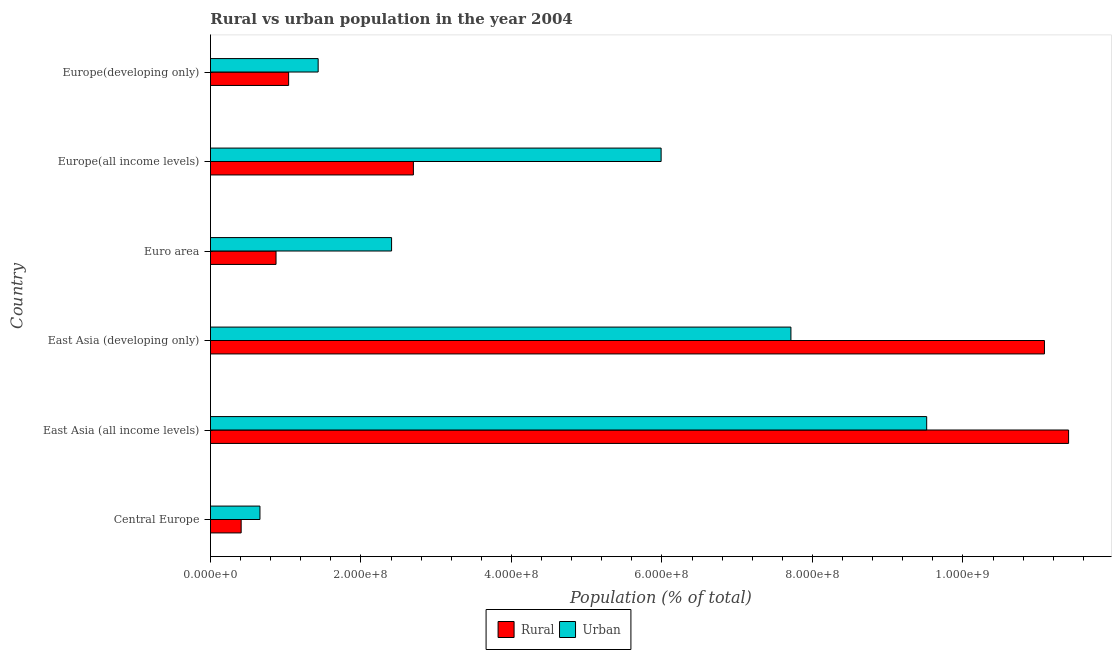How many different coloured bars are there?
Offer a terse response. 2. How many groups of bars are there?
Provide a short and direct response. 6. What is the label of the 4th group of bars from the top?
Offer a very short reply. East Asia (developing only). In how many cases, is the number of bars for a given country not equal to the number of legend labels?
Your answer should be compact. 0. What is the urban population density in Europe(developing only)?
Provide a short and direct response. 1.43e+08. Across all countries, what is the maximum rural population density?
Provide a short and direct response. 1.14e+09. Across all countries, what is the minimum urban population density?
Provide a short and direct response. 6.57e+07. In which country was the urban population density maximum?
Offer a terse response. East Asia (all income levels). In which country was the rural population density minimum?
Your response must be concise. Central Europe. What is the total urban population density in the graph?
Your response must be concise. 2.77e+09. What is the difference between the urban population density in Central Europe and that in Euro area?
Offer a terse response. -1.75e+08. What is the difference between the urban population density in Central Europe and the rural population density in Europe(all income levels)?
Offer a terse response. -2.04e+08. What is the average urban population density per country?
Keep it short and to the point. 4.62e+08. What is the difference between the urban population density and rural population density in East Asia (all income levels)?
Your response must be concise. -1.89e+08. In how many countries, is the urban population density greater than 360000000 %?
Make the answer very short. 3. What is the ratio of the urban population density in East Asia (all income levels) to that in Europe(all income levels)?
Provide a short and direct response. 1.59. Is the rural population density in Euro area less than that in Europe(all income levels)?
Your answer should be very brief. Yes. Is the difference between the rural population density in East Asia (all income levels) and Europe(all income levels) greater than the difference between the urban population density in East Asia (all income levels) and Europe(all income levels)?
Your response must be concise. Yes. What is the difference between the highest and the second highest urban population density?
Your answer should be compact. 1.80e+08. What is the difference between the highest and the lowest urban population density?
Provide a short and direct response. 8.86e+08. In how many countries, is the urban population density greater than the average urban population density taken over all countries?
Provide a succinct answer. 3. What does the 1st bar from the top in East Asia (developing only) represents?
Your response must be concise. Urban. What does the 1st bar from the bottom in Euro area represents?
Provide a short and direct response. Rural. Are all the bars in the graph horizontal?
Offer a very short reply. Yes. What is the difference between two consecutive major ticks on the X-axis?
Offer a terse response. 2.00e+08. Does the graph contain grids?
Give a very brief answer. No. What is the title of the graph?
Make the answer very short. Rural vs urban population in the year 2004. What is the label or title of the X-axis?
Offer a terse response. Population (% of total). What is the label or title of the Y-axis?
Give a very brief answer. Country. What is the Population (% of total) of Rural in Central Europe?
Your answer should be compact. 4.08e+07. What is the Population (% of total) of Urban in Central Europe?
Your response must be concise. 6.57e+07. What is the Population (% of total) in Rural in East Asia (all income levels)?
Offer a very short reply. 1.14e+09. What is the Population (% of total) in Urban in East Asia (all income levels)?
Ensure brevity in your answer.  9.52e+08. What is the Population (% of total) of Rural in East Asia (developing only)?
Offer a terse response. 1.11e+09. What is the Population (% of total) of Urban in East Asia (developing only)?
Offer a terse response. 7.71e+08. What is the Population (% of total) in Rural in Euro area?
Your answer should be very brief. 8.71e+07. What is the Population (% of total) of Urban in Euro area?
Make the answer very short. 2.41e+08. What is the Population (% of total) of Rural in Europe(all income levels)?
Your answer should be compact. 2.70e+08. What is the Population (% of total) in Urban in Europe(all income levels)?
Make the answer very short. 5.99e+08. What is the Population (% of total) of Rural in Europe(developing only)?
Ensure brevity in your answer.  1.04e+08. What is the Population (% of total) in Urban in Europe(developing only)?
Your answer should be very brief. 1.43e+08. Across all countries, what is the maximum Population (% of total) in Rural?
Offer a terse response. 1.14e+09. Across all countries, what is the maximum Population (% of total) of Urban?
Offer a very short reply. 9.52e+08. Across all countries, what is the minimum Population (% of total) in Rural?
Provide a succinct answer. 4.08e+07. Across all countries, what is the minimum Population (% of total) of Urban?
Your response must be concise. 6.57e+07. What is the total Population (% of total) in Rural in the graph?
Keep it short and to the point. 2.75e+09. What is the total Population (% of total) in Urban in the graph?
Keep it short and to the point. 2.77e+09. What is the difference between the Population (% of total) in Rural in Central Europe and that in East Asia (all income levels)?
Offer a terse response. -1.10e+09. What is the difference between the Population (% of total) of Urban in Central Europe and that in East Asia (all income levels)?
Offer a very short reply. -8.86e+08. What is the difference between the Population (% of total) in Rural in Central Europe and that in East Asia (developing only)?
Give a very brief answer. -1.07e+09. What is the difference between the Population (% of total) of Urban in Central Europe and that in East Asia (developing only)?
Provide a succinct answer. -7.06e+08. What is the difference between the Population (% of total) in Rural in Central Europe and that in Euro area?
Offer a terse response. -4.63e+07. What is the difference between the Population (% of total) in Urban in Central Europe and that in Euro area?
Keep it short and to the point. -1.75e+08. What is the difference between the Population (% of total) of Rural in Central Europe and that in Europe(all income levels)?
Give a very brief answer. -2.29e+08. What is the difference between the Population (% of total) in Urban in Central Europe and that in Europe(all income levels)?
Your answer should be compact. -5.33e+08. What is the difference between the Population (% of total) of Rural in Central Europe and that in Europe(developing only)?
Your answer should be compact. -6.31e+07. What is the difference between the Population (% of total) of Urban in Central Europe and that in Europe(developing only)?
Provide a short and direct response. -7.74e+07. What is the difference between the Population (% of total) of Rural in East Asia (all income levels) and that in East Asia (developing only)?
Offer a very short reply. 3.21e+07. What is the difference between the Population (% of total) of Urban in East Asia (all income levels) and that in East Asia (developing only)?
Your answer should be very brief. 1.80e+08. What is the difference between the Population (% of total) of Rural in East Asia (all income levels) and that in Euro area?
Give a very brief answer. 1.05e+09. What is the difference between the Population (% of total) of Urban in East Asia (all income levels) and that in Euro area?
Offer a terse response. 7.11e+08. What is the difference between the Population (% of total) of Rural in East Asia (all income levels) and that in Europe(all income levels)?
Ensure brevity in your answer.  8.71e+08. What is the difference between the Population (% of total) of Urban in East Asia (all income levels) and that in Europe(all income levels)?
Provide a short and direct response. 3.53e+08. What is the difference between the Population (% of total) in Rural in East Asia (all income levels) and that in Europe(developing only)?
Keep it short and to the point. 1.04e+09. What is the difference between the Population (% of total) of Urban in East Asia (all income levels) and that in Europe(developing only)?
Offer a very short reply. 8.09e+08. What is the difference between the Population (% of total) in Rural in East Asia (developing only) and that in Euro area?
Make the answer very short. 1.02e+09. What is the difference between the Population (% of total) of Urban in East Asia (developing only) and that in Euro area?
Ensure brevity in your answer.  5.31e+08. What is the difference between the Population (% of total) in Rural in East Asia (developing only) and that in Europe(all income levels)?
Provide a short and direct response. 8.39e+08. What is the difference between the Population (% of total) of Urban in East Asia (developing only) and that in Europe(all income levels)?
Offer a terse response. 1.72e+08. What is the difference between the Population (% of total) in Rural in East Asia (developing only) and that in Europe(developing only)?
Offer a terse response. 1.00e+09. What is the difference between the Population (% of total) in Urban in East Asia (developing only) and that in Europe(developing only)?
Your response must be concise. 6.28e+08. What is the difference between the Population (% of total) in Rural in Euro area and that in Europe(all income levels)?
Give a very brief answer. -1.83e+08. What is the difference between the Population (% of total) in Urban in Euro area and that in Europe(all income levels)?
Keep it short and to the point. -3.58e+08. What is the difference between the Population (% of total) of Rural in Euro area and that in Europe(developing only)?
Make the answer very short. -1.67e+07. What is the difference between the Population (% of total) of Urban in Euro area and that in Europe(developing only)?
Ensure brevity in your answer.  9.76e+07. What is the difference between the Population (% of total) in Rural in Europe(all income levels) and that in Europe(developing only)?
Ensure brevity in your answer.  1.66e+08. What is the difference between the Population (% of total) of Urban in Europe(all income levels) and that in Europe(developing only)?
Ensure brevity in your answer.  4.56e+08. What is the difference between the Population (% of total) of Rural in Central Europe and the Population (% of total) of Urban in East Asia (all income levels)?
Offer a terse response. -9.11e+08. What is the difference between the Population (% of total) of Rural in Central Europe and the Population (% of total) of Urban in East Asia (developing only)?
Ensure brevity in your answer.  -7.31e+08. What is the difference between the Population (% of total) in Rural in Central Europe and the Population (% of total) in Urban in Euro area?
Provide a short and direct response. -2.00e+08. What is the difference between the Population (% of total) of Rural in Central Europe and the Population (% of total) of Urban in Europe(all income levels)?
Keep it short and to the point. -5.58e+08. What is the difference between the Population (% of total) in Rural in Central Europe and the Population (% of total) in Urban in Europe(developing only)?
Offer a very short reply. -1.02e+08. What is the difference between the Population (% of total) in Rural in East Asia (all income levels) and the Population (% of total) in Urban in East Asia (developing only)?
Keep it short and to the point. 3.69e+08. What is the difference between the Population (% of total) in Rural in East Asia (all income levels) and the Population (% of total) in Urban in Euro area?
Provide a short and direct response. 9.00e+08. What is the difference between the Population (% of total) in Rural in East Asia (all income levels) and the Population (% of total) in Urban in Europe(all income levels)?
Provide a short and direct response. 5.41e+08. What is the difference between the Population (% of total) of Rural in East Asia (all income levels) and the Population (% of total) of Urban in Europe(developing only)?
Your answer should be very brief. 9.97e+08. What is the difference between the Population (% of total) in Rural in East Asia (developing only) and the Population (% of total) in Urban in Euro area?
Give a very brief answer. 8.68e+08. What is the difference between the Population (% of total) in Rural in East Asia (developing only) and the Population (% of total) in Urban in Europe(all income levels)?
Your answer should be compact. 5.09e+08. What is the difference between the Population (% of total) in Rural in East Asia (developing only) and the Population (% of total) in Urban in Europe(developing only)?
Ensure brevity in your answer.  9.65e+08. What is the difference between the Population (% of total) in Rural in Euro area and the Population (% of total) in Urban in Europe(all income levels)?
Your answer should be very brief. -5.12e+08. What is the difference between the Population (% of total) in Rural in Euro area and the Population (% of total) in Urban in Europe(developing only)?
Make the answer very short. -5.60e+07. What is the difference between the Population (% of total) of Rural in Europe(all income levels) and the Population (% of total) of Urban in Europe(developing only)?
Ensure brevity in your answer.  1.27e+08. What is the average Population (% of total) in Rural per country?
Your answer should be very brief. 4.58e+08. What is the average Population (% of total) in Urban per country?
Provide a succinct answer. 4.62e+08. What is the difference between the Population (% of total) of Rural and Population (% of total) of Urban in Central Europe?
Ensure brevity in your answer.  -2.50e+07. What is the difference between the Population (% of total) of Rural and Population (% of total) of Urban in East Asia (all income levels)?
Ensure brevity in your answer.  1.89e+08. What is the difference between the Population (% of total) in Rural and Population (% of total) in Urban in East Asia (developing only)?
Provide a succinct answer. 3.37e+08. What is the difference between the Population (% of total) in Rural and Population (% of total) in Urban in Euro area?
Your response must be concise. -1.54e+08. What is the difference between the Population (% of total) in Rural and Population (% of total) in Urban in Europe(all income levels)?
Your answer should be compact. -3.29e+08. What is the difference between the Population (% of total) of Rural and Population (% of total) of Urban in Europe(developing only)?
Provide a succinct answer. -3.93e+07. What is the ratio of the Population (% of total) in Rural in Central Europe to that in East Asia (all income levels)?
Offer a terse response. 0.04. What is the ratio of the Population (% of total) of Urban in Central Europe to that in East Asia (all income levels)?
Your answer should be compact. 0.07. What is the ratio of the Population (% of total) in Rural in Central Europe to that in East Asia (developing only)?
Keep it short and to the point. 0.04. What is the ratio of the Population (% of total) in Urban in Central Europe to that in East Asia (developing only)?
Make the answer very short. 0.09. What is the ratio of the Population (% of total) of Rural in Central Europe to that in Euro area?
Give a very brief answer. 0.47. What is the ratio of the Population (% of total) in Urban in Central Europe to that in Euro area?
Your answer should be compact. 0.27. What is the ratio of the Population (% of total) of Rural in Central Europe to that in Europe(all income levels)?
Offer a very short reply. 0.15. What is the ratio of the Population (% of total) in Urban in Central Europe to that in Europe(all income levels)?
Provide a succinct answer. 0.11. What is the ratio of the Population (% of total) of Rural in Central Europe to that in Europe(developing only)?
Keep it short and to the point. 0.39. What is the ratio of the Population (% of total) in Urban in Central Europe to that in Europe(developing only)?
Ensure brevity in your answer.  0.46. What is the ratio of the Population (% of total) in Rural in East Asia (all income levels) to that in East Asia (developing only)?
Provide a short and direct response. 1.03. What is the ratio of the Population (% of total) in Urban in East Asia (all income levels) to that in East Asia (developing only)?
Provide a succinct answer. 1.23. What is the ratio of the Population (% of total) in Rural in East Asia (all income levels) to that in Euro area?
Your answer should be compact. 13.09. What is the ratio of the Population (% of total) of Urban in East Asia (all income levels) to that in Euro area?
Your answer should be very brief. 3.95. What is the ratio of the Population (% of total) in Rural in East Asia (all income levels) to that in Europe(all income levels)?
Ensure brevity in your answer.  4.23. What is the ratio of the Population (% of total) in Urban in East Asia (all income levels) to that in Europe(all income levels)?
Give a very brief answer. 1.59. What is the ratio of the Population (% of total) of Rural in East Asia (all income levels) to that in Europe(developing only)?
Your response must be concise. 10.98. What is the ratio of the Population (% of total) of Urban in East Asia (all income levels) to that in Europe(developing only)?
Keep it short and to the point. 6.65. What is the ratio of the Population (% of total) of Rural in East Asia (developing only) to that in Euro area?
Your response must be concise. 12.72. What is the ratio of the Population (% of total) of Urban in East Asia (developing only) to that in Euro area?
Your response must be concise. 3.21. What is the ratio of the Population (% of total) in Rural in East Asia (developing only) to that in Europe(all income levels)?
Provide a short and direct response. 4.11. What is the ratio of the Population (% of total) of Urban in East Asia (developing only) to that in Europe(all income levels)?
Keep it short and to the point. 1.29. What is the ratio of the Population (% of total) in Rural in East Asia (developing only) to that in Europe(developing only)?
Give a very brief answer. 10.67. What is the ratio of the Population (% of total) of Urban in East Asia (developing only) to that in Europe(developing only)?
Make the answer very short. 5.39. What is the ratio of the Population (% of total) in Rural in Euro area to that in Europe(all income levels)?
Make the answer very short. 0.32. What is the ratio of the Population (% of total) of Urban in Euro area to that in Europe(all income levels)?
Your response must be concise. 0.4. What is the ratio of the Population (% of total) of Rural in Euro area to that in Europe(developing only)?
Provide a succinct answer. 0.84. What is the ratio of the Population (% of total) in Urban in Euro area to that in Europe(developing only)?
Give a very brief answer. 1.68. What is the ratio of the Population (% of total) of Rural in Europe(all income levels) to that in Europe(developing only)?
Keep it short and to the point. 2.6. What is the ratio of the Population (% of total) of Urban in Europe(all income levels) to that in Europe(developing only)?
Provide a succinct answer. 4.18. What is the difference between the highest and the second highest Population (% of total) of Rural?
Give a very brief answer. 3.21e+07. What is the difference between the highest and the second highest Population (% of total) in Urban?
Provide a succinct answer. 1.80e+08. What is the difference between the highest and the lowest Population (% of total) of Rural?
Provide a succinct answer. 1.10e+09. What is the difference between the highest and the lowest Population (% of total) in Urban?
Keep it short and to the point. 8.86e+08. 